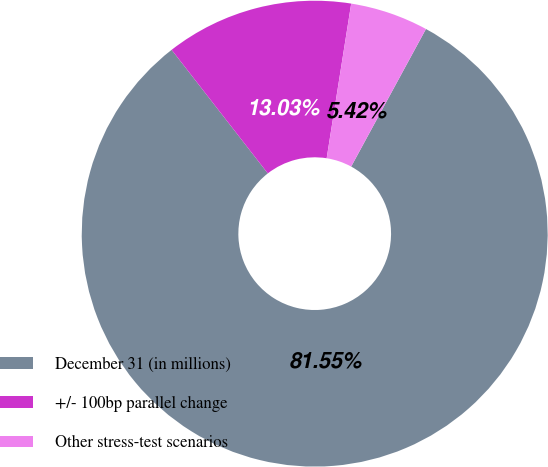Convert chart to OTSL. <chart><loc_0><loc_0><loc_500><loc_500><pie_chart><fcel>December 31 (in millions)<fcel>+/- 100bp parallel change<fcel>Other stress-test scenarios<nl><fcel>81.55%<fcel>13.03%<fcel>5.42%<nl></chart> 